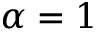<formula> <loc_0><loc_0><loc_500><loc_500>\alpha = 1</formula> 